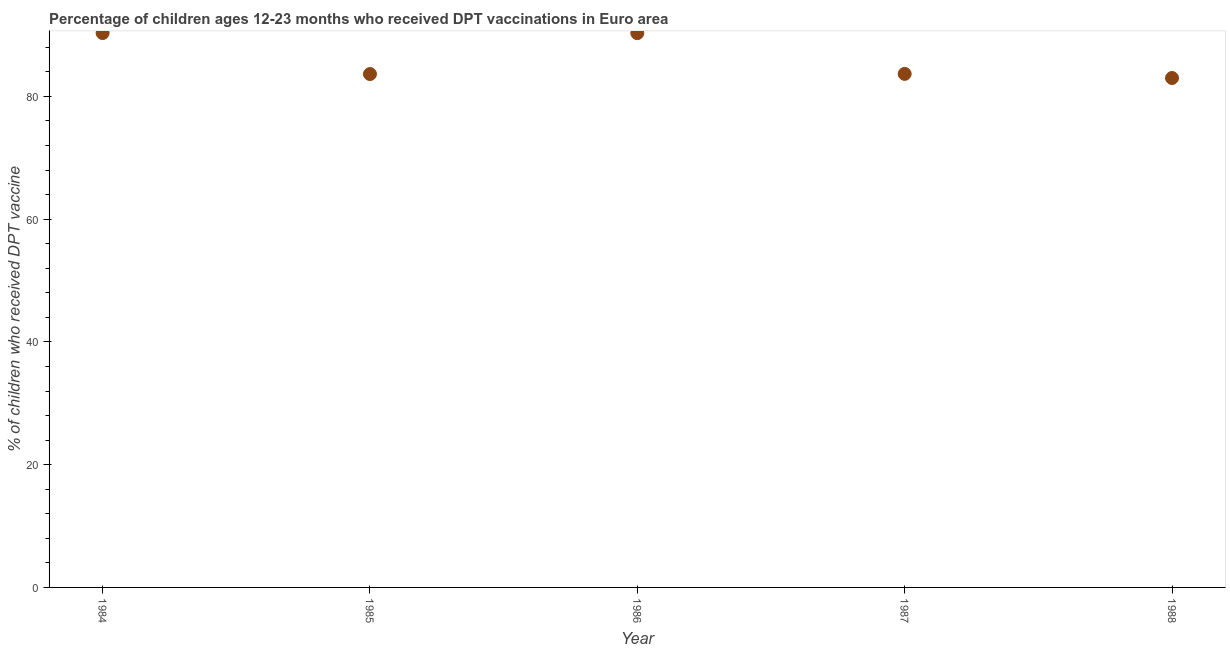What is the percentage of children who received dpt vaccine in 1985?
Your answer should be very brief. 83.65. Across all years, what is the maximum percentage of children who received dpt vaccine?
Provide a short and direct response. 90.33. Across all years, what is the minimum percentage of children who received dpt vaccine?
Make the answer very short. 83. In which year was the percentage of children who received dpt vaccine maximum?
Provide a succinct answer. 1984. In which year was the percentage of children who received dpt vaccine minimum?
Keep it short and to the point. 1988. What is the sum of the percentage of children who received dpt vaccine?
Ensure brevity in your answer.  430.97. What is the difference between the percentage of children who received dpt vaccine in 1984 and 1987?
Your answer should be very brief. 6.65. What is the average percentage of children who received dpt vaccine per year?
Offer a terse response. 86.19. What is the median percentage of children who received dpt vaccine?
Provide a succinct answer. 83.68. What is the ratio of the percentage of children who received dpt vaccine in 1985 to that in 1987?
Offer a very short reply. 1. Is the difference between the percentage of children who received dpt vaccine in 1985 and 1987 greater than the difference between any two years?
Give a very brief answer. No. What is the difference between the highest and the second highest percentage of children who received dpt vaccine?
Keep it short and to the point. 0.01. Is the sum of the percentage of children who received dpt vaccine in 1984 and 1985 greater than the maximum percentage of children who received dpt vaccine across all years?
Offer a terse response. Yes. What is the difference between the highest and the lowest percentage of children who received dpt vaccine?
Keep it short and to the point. 7.32. In how many years, is the percentage of children who received dpt vaccine greater than the average percentage of children who received dpt vaccine taken over all years?
Give a very brief answer. 2. Does the percentage of children who received dpt vaccine monotonically increase over the years?
Provide a short and direct response. No. How many dotlines are there?
Keep it short and to the point. 1. How many years are there in the graph?
Your response must be concise. 5. Are the values on the major ticks of Y-axis written in scientific E-notation?
Make the answer very short. No. Does the graph contain grids?
Provide a short and direct response. No. What is the title of the graph?
Offer a terse response. Percentage of children ages 12-23 months who received DPT vaccinations in Euro area. What is the label or title of the Y-axis?
Your response must be concise. % of children who received DPT vaccine. What is the % of children who received DPT vaccine in 1984?
Your answer should be compact. 90.33. What is the % of children who received DPT vaccine in 1985?
Offer a terse response. 83.65. What is the % of children who received DPT vaccine in 1986?
Offer a very short reply. 90.31. What is the % of children who received DPT vaccine in 1987?
Offer a terse response. 83.68. What is the % of children who received DPT vaccine in 1988?
Keep it short and to the point. 83. What is the difference between the % of children who received DPT vaccine in 1984 and 1985?
Your response must be concise. 6.68. What is the difference between the % of children who received DPT vaccine in 1984 and 1986?
Give a very brief answer. 0.01. What is the difference between the % of children who received DPT vaccine in 1984 and 1987?
Make the answer very short. 6.65. What is the difference between the % of children who received DPT vaccine in 1984 and 1988?
Your answer should be compact. 7.32. What is the difference between the % of children who received DPT vaccine in 1985 and 1986?
Your response must be concise. -6.66. What is the difference between the % of children who received DPT vaccine in 1985 and 1987?
Provide a succinct answer. -0.03. What is the difference between the % of children who received DPT vaccine in 1985 and 1988?
Provide a short and direct response. 0.65. What is the difference between the % of children who received DPT vaccine in 1986 and 1987?
Provide a succinct answer. 6.64. What is the difference between the % of children who received DPT vaccine in 1986 and 1988?
Provide a short and direct response. 7.31. What is the difference between the % of children who received DPT vaccine in 1987 and 1988?
Provide a short and direct response. 0.67. What is the ratio of the % of children who received DPT vaccine in 1984 to that in 1985?
Your answer should be very brief. 1.08. What is the ratio of the % of children who received DPT vaccine in 1984 to that in 1987?
Your answer should be very brief. 1.08. What is the ratio of the % of children who received DPT vaccine in 1984 to that in 1988?
Offer a very short reply. 1.09. What is the ratio of the % of children who received DPT vaccine in 1985 to that in 1986?
Your answer should be very brief. 0.93. What is the ratio of the % of children who received DPT vaccine in 1986 to that in 1987?
Give a very brief answer. 1.08. What is the ratio of the % of children who received DPT vaccine in 1986 to that in 1988?
Provide a succinct answer. 1.09. What is the ratio of the % of children who received DPT vaccine in 1987 to that in 1988?
Keep it short and to the point. 1.01. 